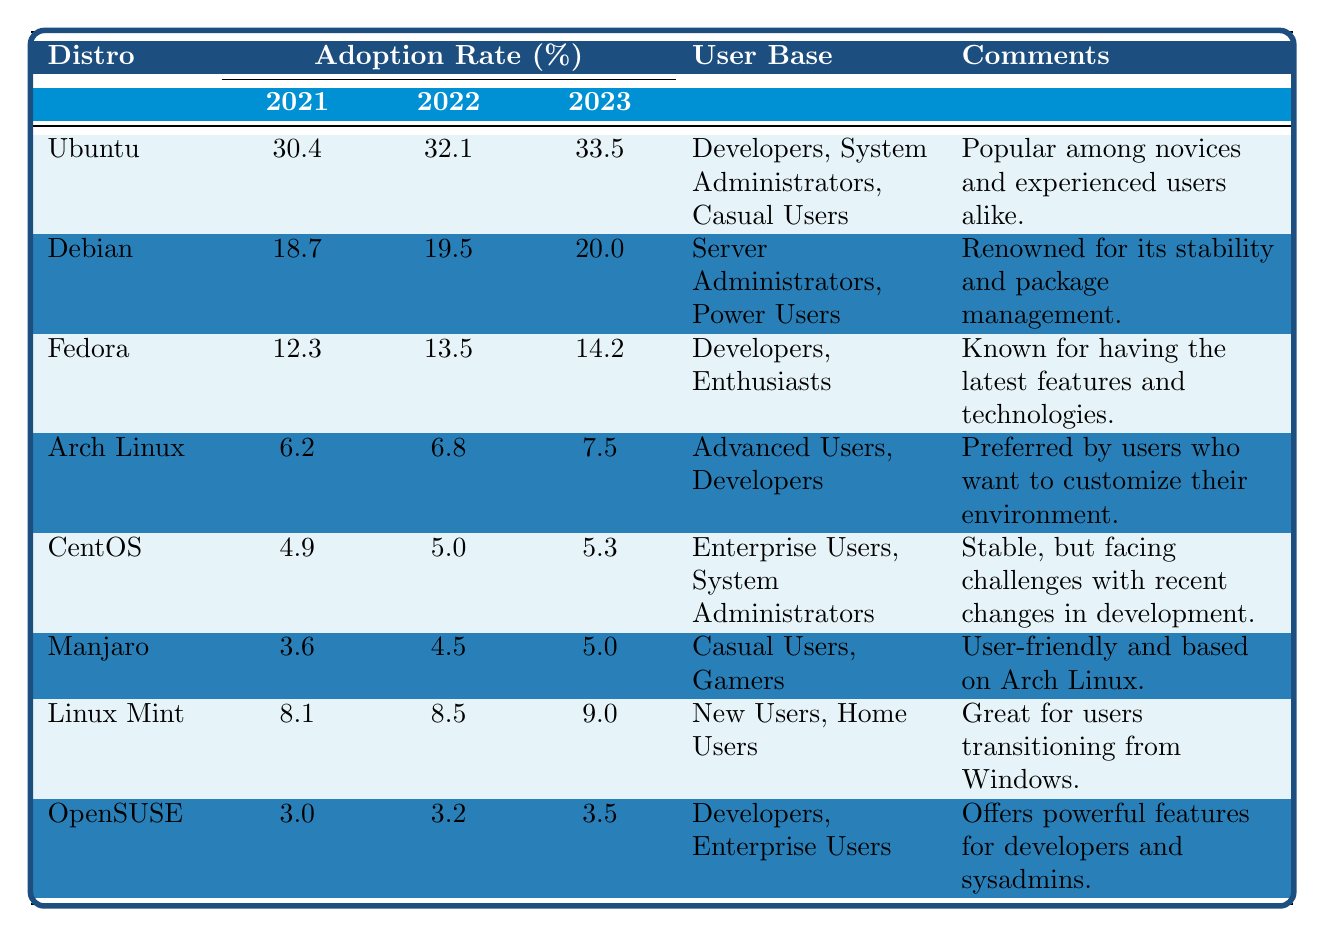What was the user adoption rate of Ubuntu in 2022? According to the table, the user adoption rate of Ubuntu in 2022 is listed as 32.1%.
Answer: 32.1% Which Linux distro had the highest user adoption rate in 2023? The table shows that Ubuntu had the highest user adoption rate of 33.5% in 2023, compared to all other listed distros.
Answer: Ubuntu What percentage did Debian's adoption rate increase from 2021 to 2023? Debian's adoption rate in 2021 was 18.7%, and in 2023, it was 20.0%. The increase is calculated as 20.0% - 18.7% = 1.3%.
Answer: 1.3% True or False: Manjaro had a higher user adoption rate than CentOS in 2021. The table indicates that Manjaro had a user adoption rate of 3.6% while CentOS had 4.9% in 2021, meaning CentOS was higher. Therefore, the statement is False.
Answer: False What is the total user adoption rate of Fedora and Arch Linux in 2023? The adoption rate for Fedora in 2023 is 14.2% and for Arch Linux, it is 7.5%. Adding these two gives us 14.2% + 7.5% = 21.7%.
Answer: 21.7% Which two distros had an adoption rate above 30% in 2023? In the table, the only distro with an adoption rate above 30% in 2023 is Ubuntu with 33.5%. No other distro meets this criterion.
Answer: Only Ubuntu What is the average user adoption rate for Linux Mint from 2021 to 2023? The adoption rates for Linux Mint are 8.1% (2021), 8.5% (2022), and 9.0% (2023). To find the average, we sum these values: 8.1 + 8.5 + 9.0 = 25.6, then divide by 3, yielding 25.6 / 3 = 8.53.
Answer: 8.53 Did OpenSUSE increase its adoption rate from 2021 to 2023? The table shows OpenSUSE's adoption rates were 3.0% in 2021 and 3.5% in 2023. Since 3.5% is greater than 3.0%, it indicates an increase.
Answer: Yes What is the difference between the adoption rates of CentOS and Ubuntu in 2022? In 2022, Ubuntu's rate was 32.1% and CentOS's rate was 5.0%. The difference is calculated as 32.1% - 5.0% = 27.1%.
Answer: 27.1% Which distro had the lowest adoption rate in 2021? The table shows that OpenSUSE had the lowest adoption rate in 2021 at 3.0%.
Answer: OpenSUSE 